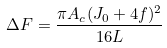Convert formula to latex. <formula><loc_0><loc_0><loc_500><loc_500>\Delta F = \frac { \pi A _ { c } ( J _ { 0 } + 4 f ) ^ { 2 } } { 1 6 L }</formula> 